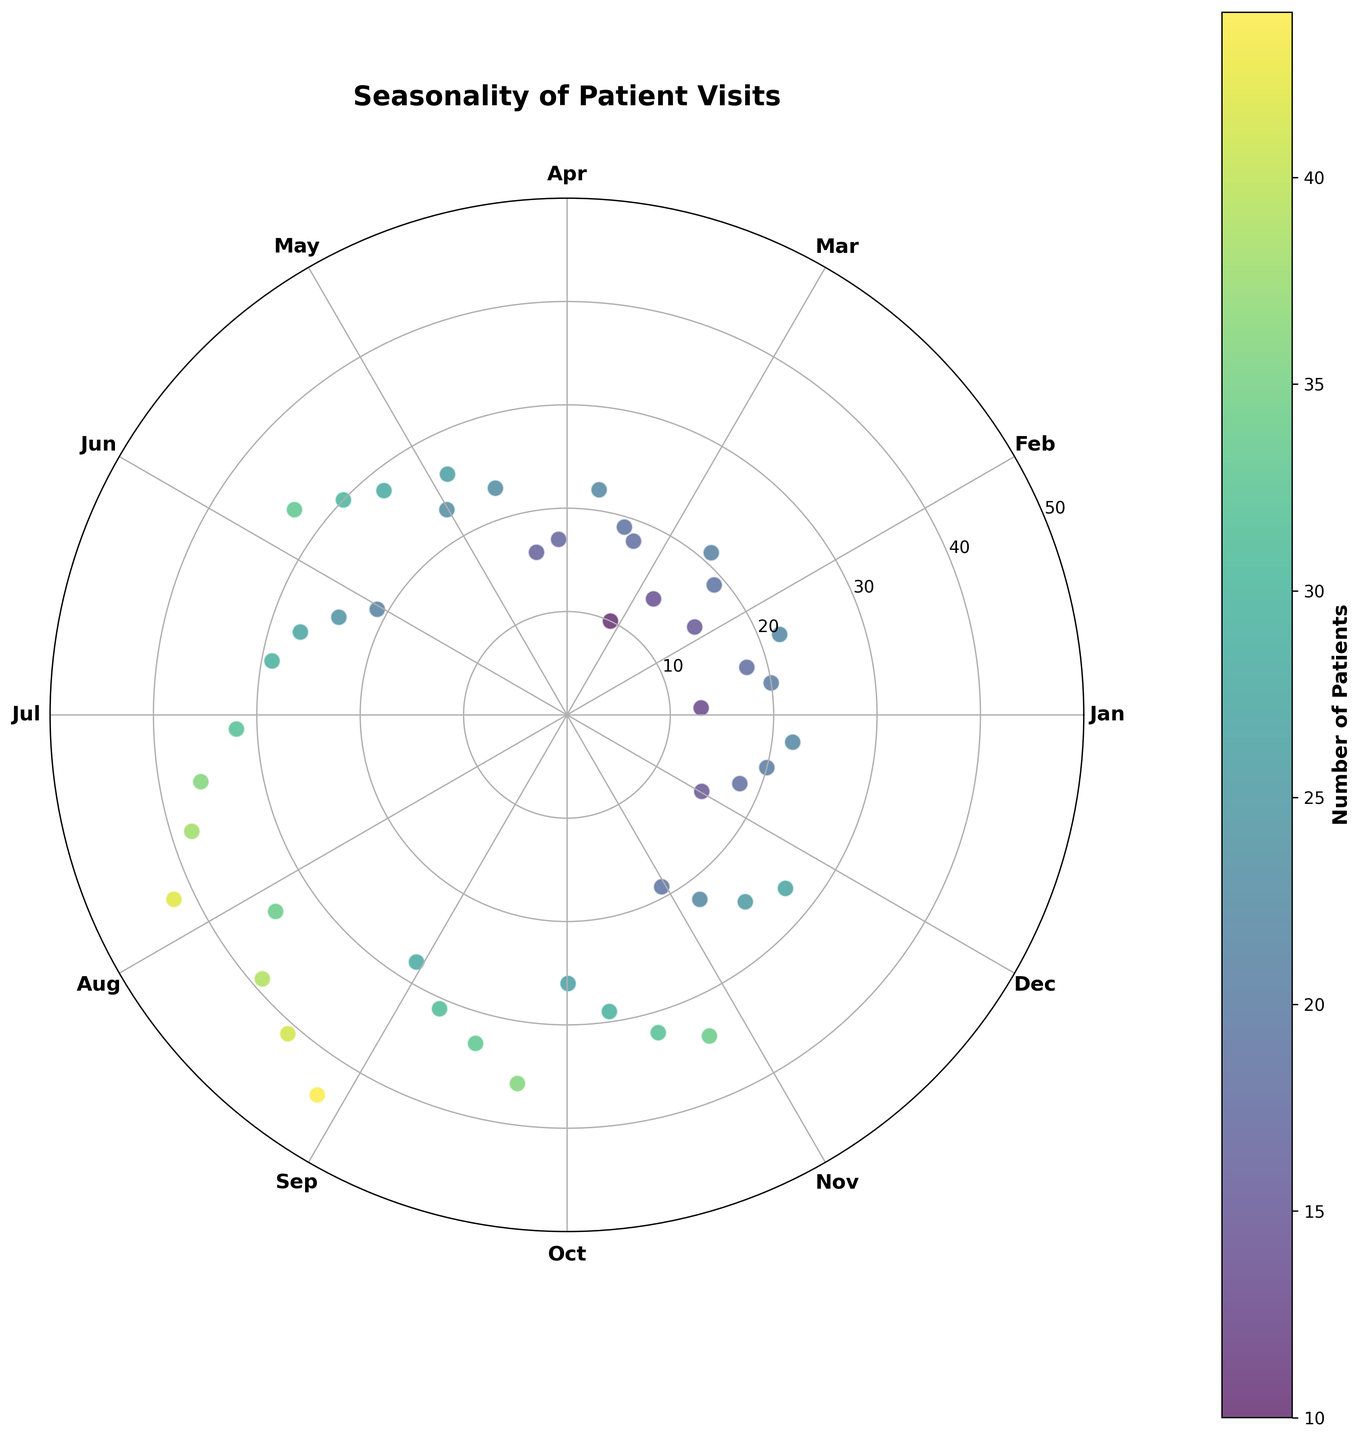How many months have data points in the figure? To determine the number of months with data points in the figure, observe the labels around the polar chart. There are data points for each month from January to December.
Answer: 12 Which month has the highest patient visit data point? Inspect the angle around the polar chart where data points are plotted. The highest value (44) is located in August.
Answer: August What's the range of patient visit counts shown in the figure? To find the range, identify the smallest and largest patient visit counts in the data points, which are 10 and 44, respectively. The range is the difference between these two values (44 - 10).
Answer: 34 Compare July and October. Which month shows a higher maximum number of patient visits? Look at the data points for July and October. The highest value for July is 42, while for October it is 34. Thus, July has a higher maximum number of patient visits.
Answer: July What is the average patient visit count in March? Find the patient visit counts for March, which are 10, 18, 19, and 22. Calculate their average by summing them up (10 + 18 + 19 + 22 = 69) and then dividing by 4 (69 / 4).
Answer: 17.25 What is the median patient visit count in November? List the patient visit counts for November in ascending order (19, 22, 25, 27). The median is the average of the two middle values (22 and 25), which is (22 + 25) / 2.
Answer: 23.5 During which month does the variation in patient visits appear to be the largest? To determine the month with the largest variation, visually inspect the distribution of data points within each month. August's data points range from 34 to 44, indicating high variation.
Answer: August Which month has the least variation in patient visits? Identify the month with data points that are most closely clustered together. For April, the values range from 16 to 26, showing relatively low variation compared to other months.
Answer: April Is there a visible trend in patient visits over the year? By observing the general pattern of data points around the polar chart, there is a visible trend of increasing patient visits from January to August and then a slight decrease towards December.
Answer: Yes Which months have data points reaching or exceeding 30 patient visits? Check for data points on the chart with values of 30 or more. These months are May (30, 33), June (27, 29), July (32, 36, 38, 42), August (34, 39, 41, 44), and September (31, 33, 36).
Answer: May, June, July, August, September 